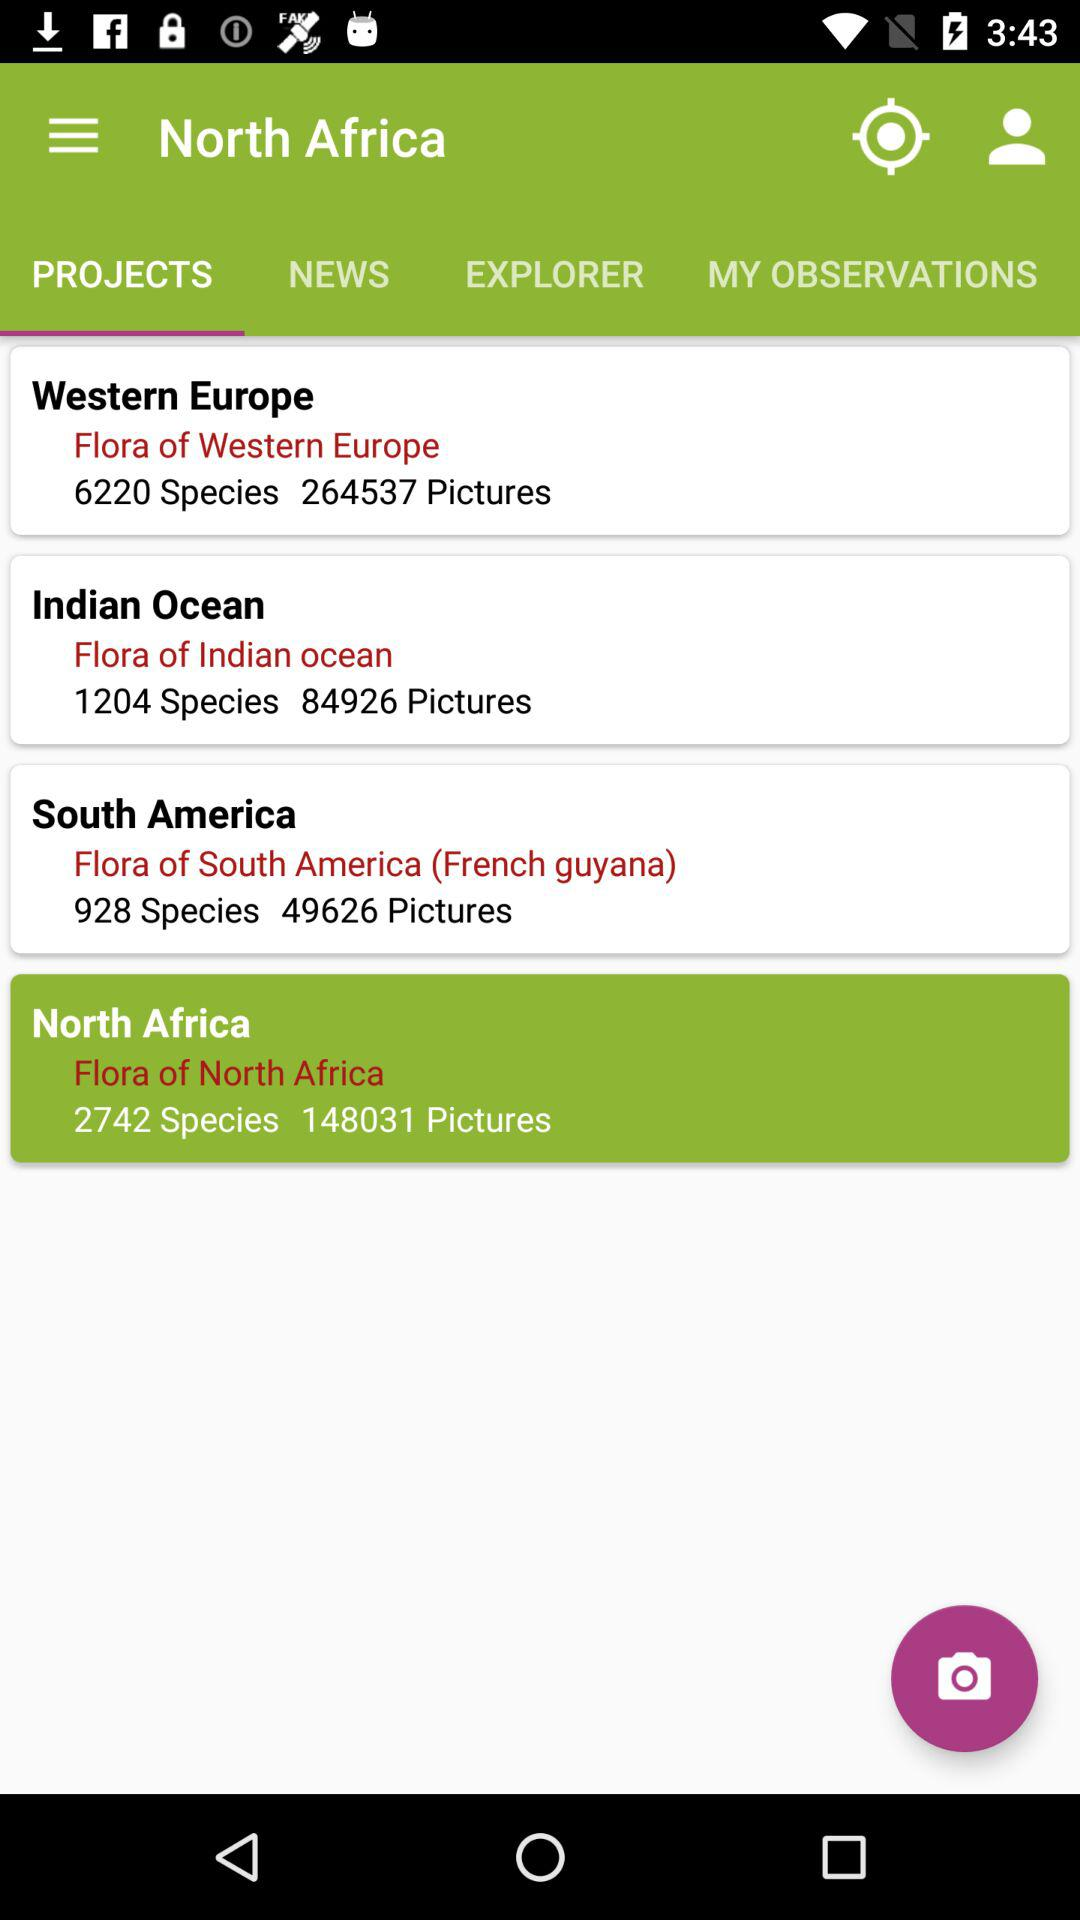What's the number of pictures in "Flora of Indian ocean"? The number of pictures in "Flora of Indian ocean" is 84926. 